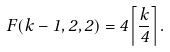Convert formula to latex. <formula><loc_0><loc_0><loc_500><loc_500>F ( k - 1 , 2 , 2 ) = 4 \left \lceil \frac { k } { 4 } \right \rceil .</formula> 